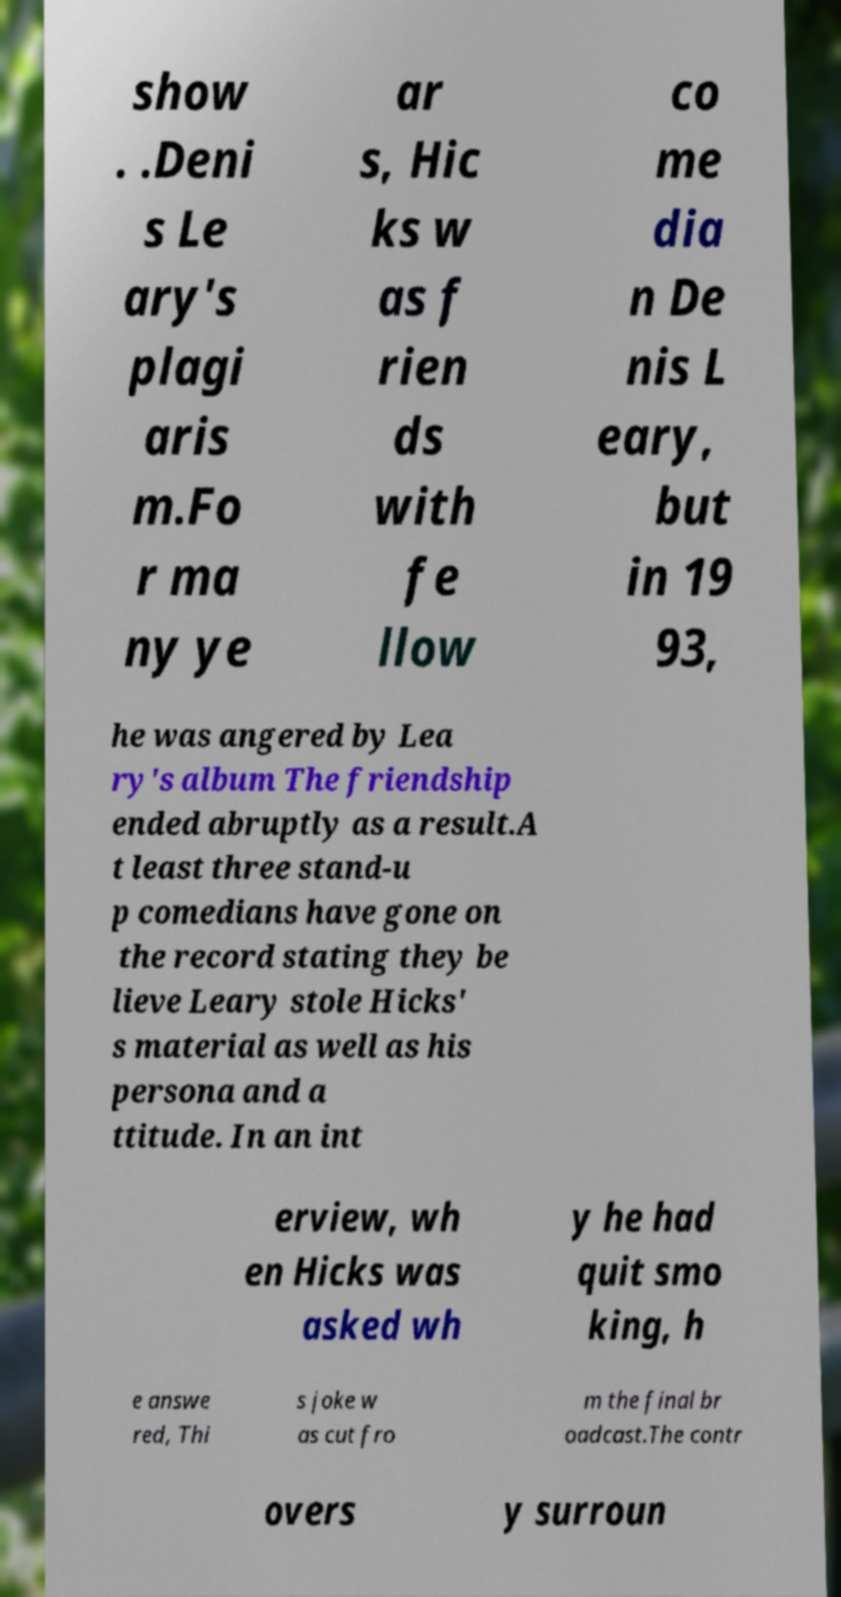Please identify and transcribe the text found in this image. show . .Deni s Le ary's plagi aris m.Fo r ma ny ye ar s, Hic ks w as f rien ds with fe llow co me dia n De nis L eary, but in 19 93, he was angered by Lea ry's album The friendship ended abruptly as a result.A t least three stand-u p comedians have gone on the record stating they be lieve Leary stole Hicks' s material as well as his persona and a ttitude. In an int erview, wh en Hicks was asked wh y he had quit smo king, h e answe red, Thi s joke w as cut fro m the final br oadcast.The contr overs y surroun 